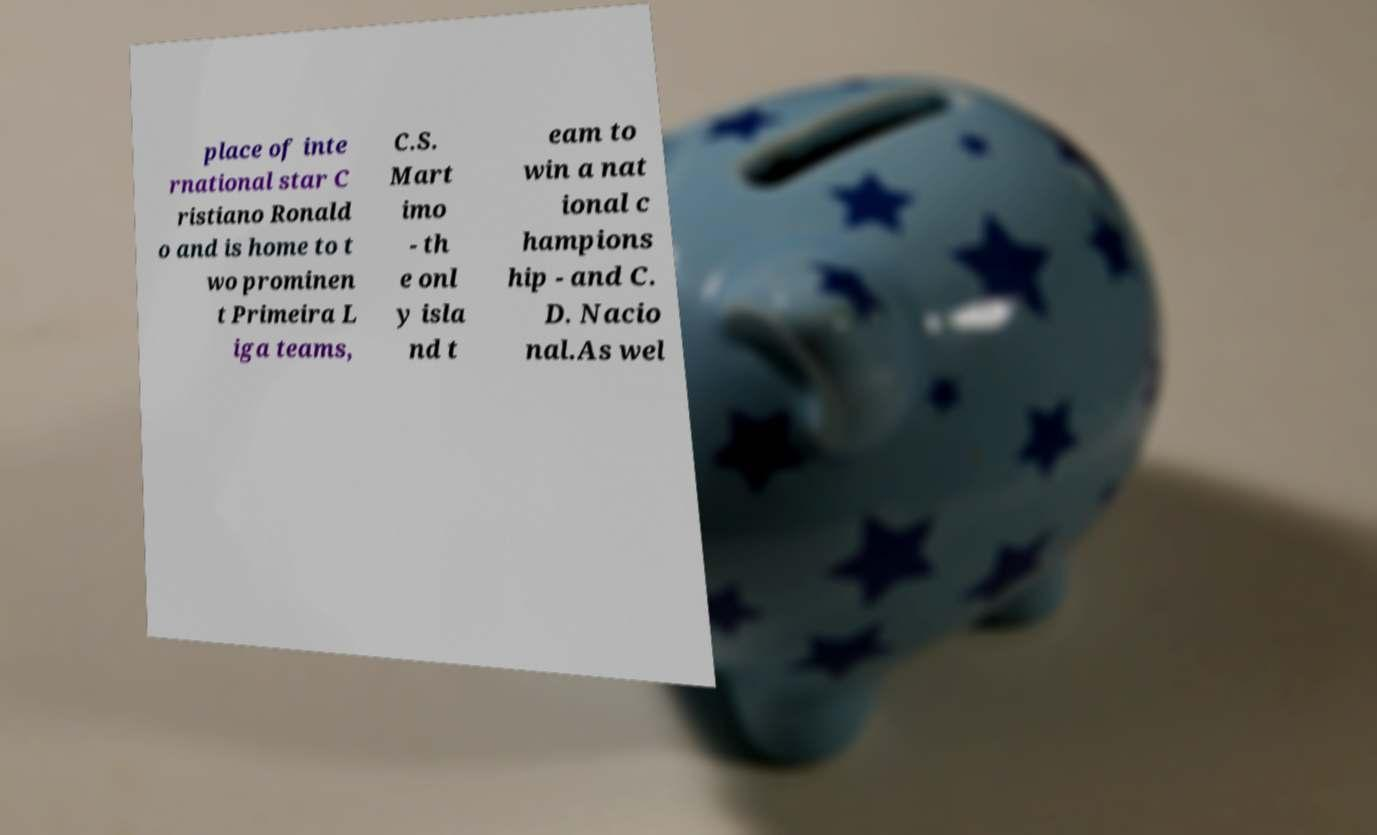What messages or text are displayed in this image? I need them in a readable, typed format. place of inte rnational star C ristiano Ronald o and is home to t wo prominen t Primeira L iga teams, C.S. Mart imo - th e onl y isla nd t eam to win a nat ional c hampions hip - and C. D. Nacio nal.As wel 